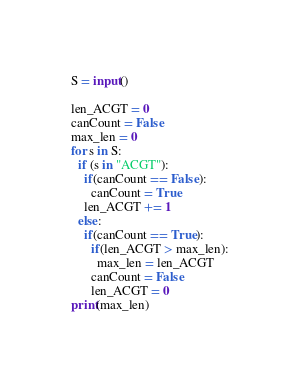<code> <loc_0><loc_0><loc_500><loc_500><_Python_>S = input()

len_ACGT = 0
canCount = False
max_len = 0
for s in S:
  if (s in "ACGT"):
    if(canCount == False):
      canCount = True
    len_ACGT += 1
  else:
    if(canCount == True):
      if(len_ACGT > max_len):
        max_len = len_ACGT
      canCount = False
      len_ACGT = 0
print(max_len)</code> 